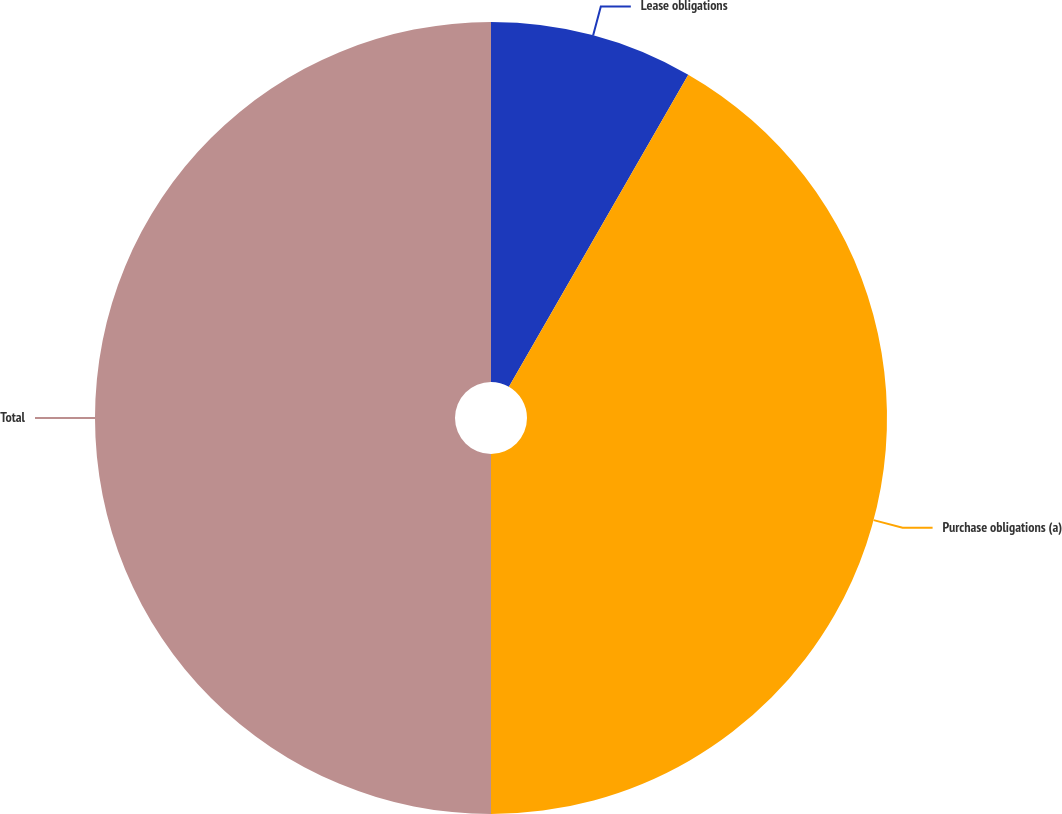Convert chart. <chart><loc_0><loc_0><loc_500><loc_500><pie_chart><fcel>Lease obligations<fcel>Purchase obligations (a)<fcel>Total<nl><fcel>8.3%<fcel>41.7%<fcel>50.0%<nl></chart> 